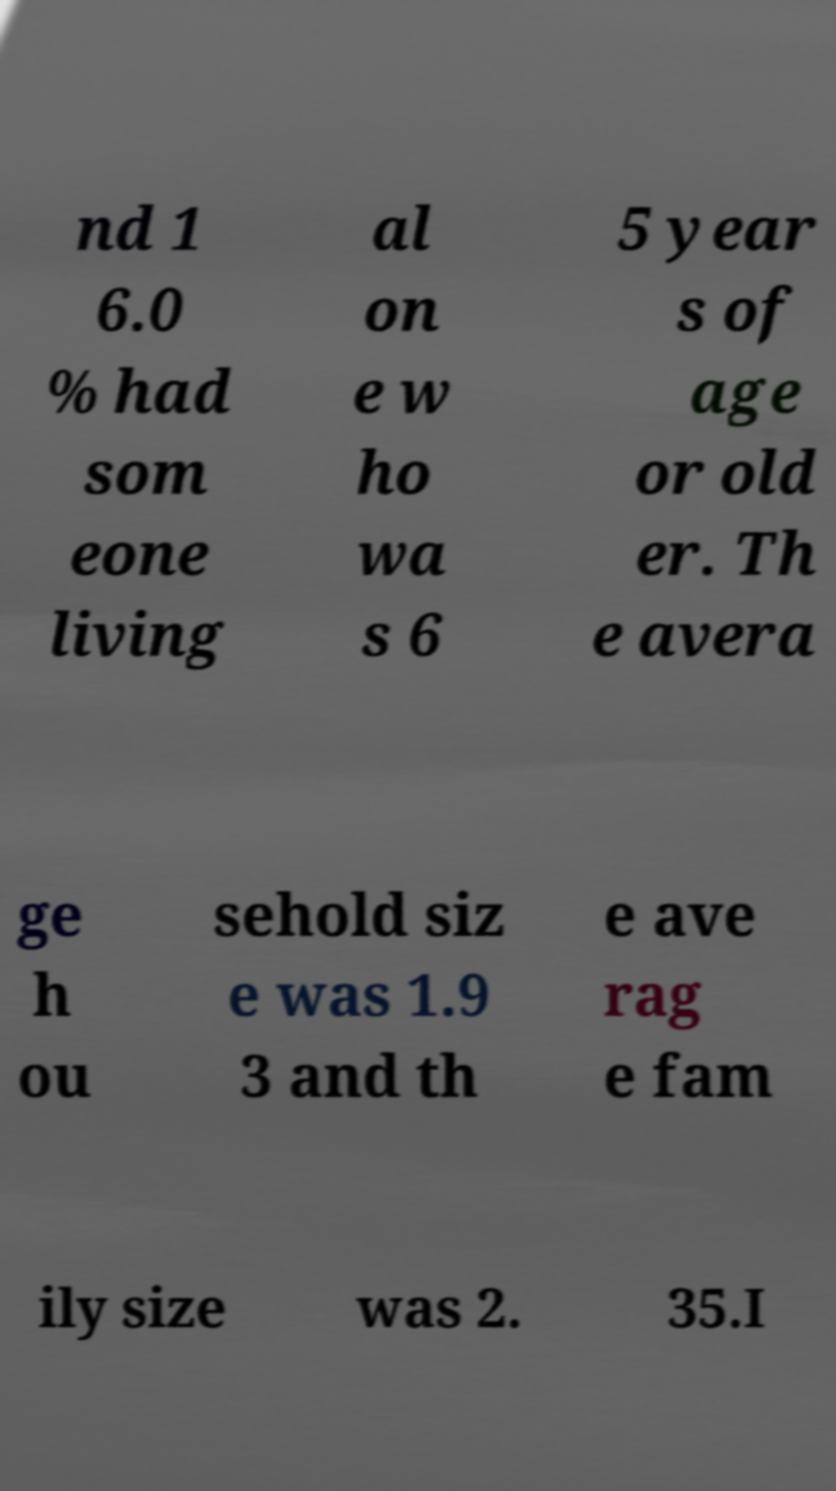Please read and relay the text visible in this image. What does it say? nd 1 6.0 % had som eone living al on e w ho wa s 6 5 year s of age or old er. Th e avera ge h ou sehold siz e was 1.9 3 and th e ave rag e fam ily size was 2. 35.I 